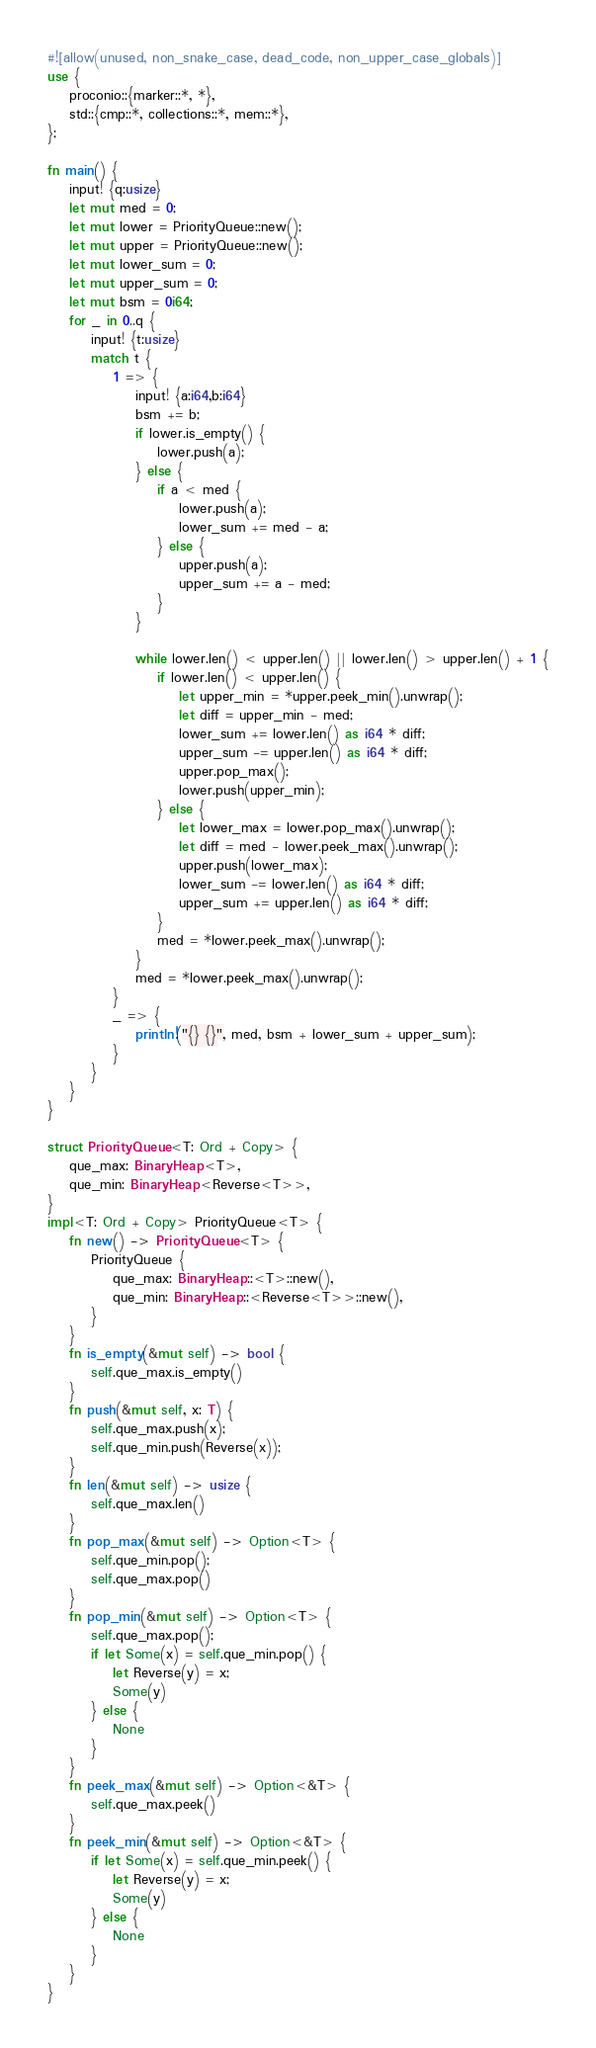<code> <loc_0><loc_0><loc_500><loc_500><_Rust_>#![allow(unused, non_snake_case, dead_code, non_upper_case_globals)]
use {
    proconio::{marker::*, *},
    std::{cmp::*, collections::*, mem::*},
};

fn main() {
    input! {q:usize}
    let mut med = 0;
    let mut lower = PriorityQueue::new();
    let mut upper = PriorityQueue::new();
    let mut lower_sum = 0;
    let mut upper_sum = 0;
    let mut bsm = 0i64;
    for _ in 0..q {
        input! {t:usize}
        match t {
            1 => {
                input! {a:i64,b:i64}
                bsm += b;
                if lower.is_empty() {
                    lower.push(a);
                } else {
                    if a < med {
                        lower.push(a);
                        lower_sum += med - a;
                    } else {
                        upper.push(a);
                        upper_sum += a - med;
                    }
                }

                while lower.len() < upper.len() || lower.len() > upper.len() + 1 {
                    if lower.len() < upper.len() {
                        let upper_min = *upper.peek_min().unwrap();
                        let diff = upper_min - med;
                        lower_sum += lower.len() as i64 * diff;
                        upper_sum -= upper.len() as i64 * diff;
                        upper.pop_max();
                        lower.push(upper_min);
                    } else {
                        let lower_max = lower.pop_max().unwrap();
                        let diff = med - lower.peek_max().unwrap();
                        upper.push(lower_max);
                        lower_sum -= lower.len() as i64 * diff;
                        upper_sum += upper.len() as i64 * diff;
                    }
                    med = *lower.peek_max().unwrap();
                }
                med = *lower.peek_max().unwrap();
            }
            _ => {
                println!("{} {}", med, bsm + lower_sum + upper_sum);
            }
        }
    }
}

struct PriorityQueue<T: Ord + Copy> {
    que_max: BinaryHeap<T>,
    que_min: BinaryHeap<Reverse<T>>,
}
impl<T: Ord + Copy> PriorityQueue<T> {
    fn new() -> PriorityQueue<T> {
        PriorityQueue {
            que_max: BinaryHeap::<T>::new(),
            que_min: BinaryHeap::<Reverse<T>>::new(),
        }
    }
    fn is_empty(&mut self) -> bool {
        self.que_max.is_empty()
    }
    fn push(&mut self, x: T) {
        self.que_max.push(x);
        self.que_min.push(Reverse(x));
    }
    fn len(&mut self) -> usize {
        self.que_max.len()
    }
    fn pop_max(&mut self) -> Option<T> {
        self.que_min.pop();
        self.que_max.pop()
    }
    fn pop_min(&mut self) -> Option<T> {
        self.que_max.pop();
        if let Some(x) = self.que_min.pop() {
            let Reverse(y) = x;
            Some(y)
        } else {
            None
        }
    }
    fn peek_max(&mut self) -> Option<&T> {
        self.que_max.peek()
    }
    fn peek_min(&mut self) -> Option<&T> {
        if let Some(x) = self.que_min.peek() {
            let Reverse(y) = x;
            Some(y)
        } else {
            None
        }
    }
}
</code> 